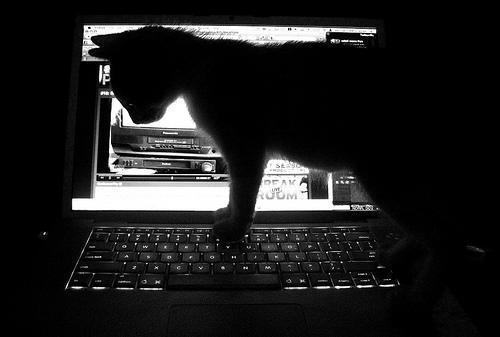How many cats are visible?
Give a very brief answer. 1. How many ears are visible on the cat?
Give a very brief answer. 2. How many cats are there?
Give a very brief answer. 1. How many ears does the cat have?
Give a very brief answer. 2. 